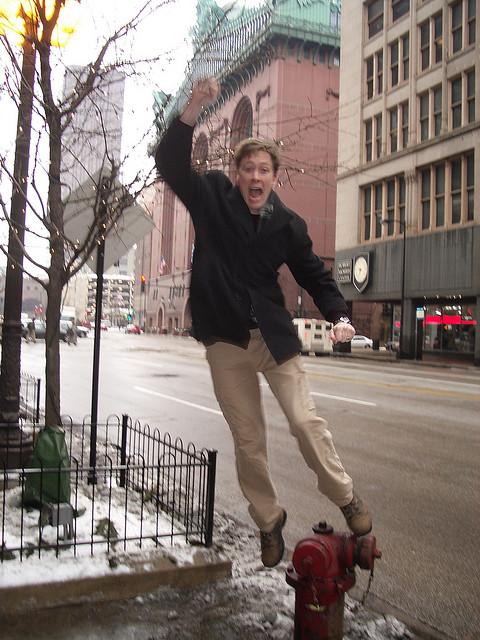What season of the year is it?
Be succinct. Winter. What pattern is the man's pants?
Be succinct. Solid. Is there a train coming?
Give a very brief answer. No. Does the man appear to be waiting?
Keep it brief. No. Is the man wealthy?
Short answer required. No. Where is the boy?
Be succinct. Outside. Is this person jumping off of the fire hydrant?
Concise answer only. Yes. What season is it?
Give a very brief answer. Winter. 